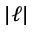<formula> <loc_0><loc_0><loc_500><loc_500>| \ell |</formula> 